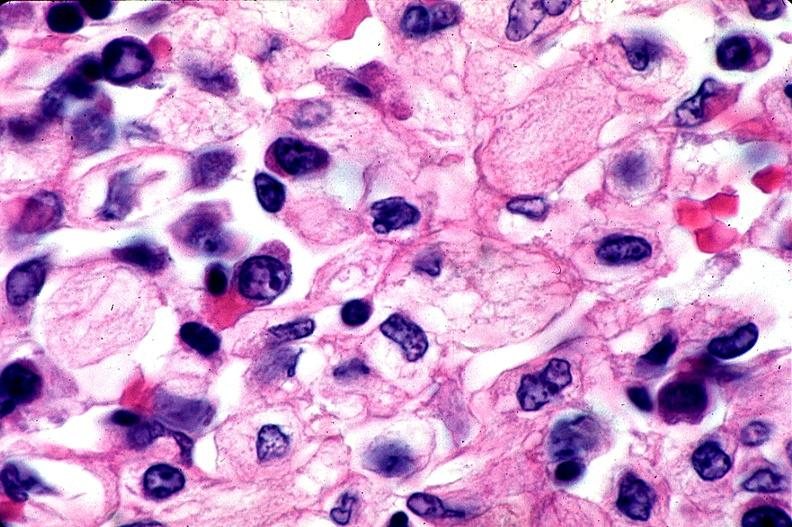what is present?
Answer the question using a single word or phrase. Hematologic 